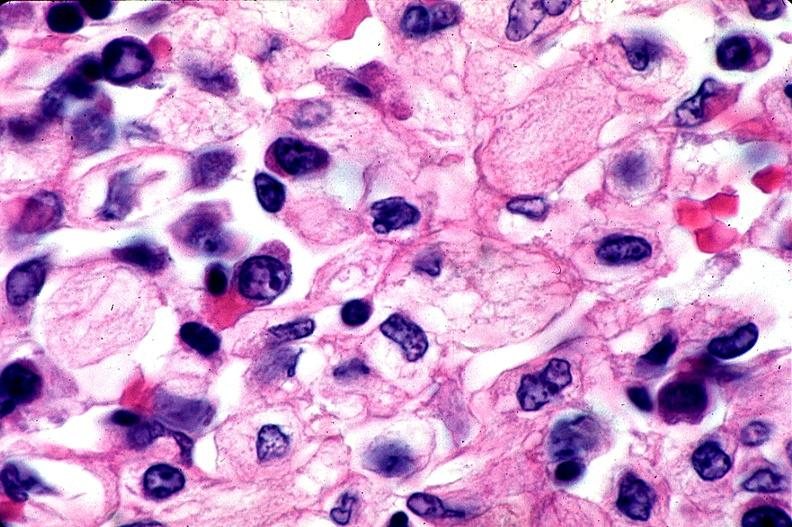what is present?
Answer the question using a single word or phrase. Hematologic 